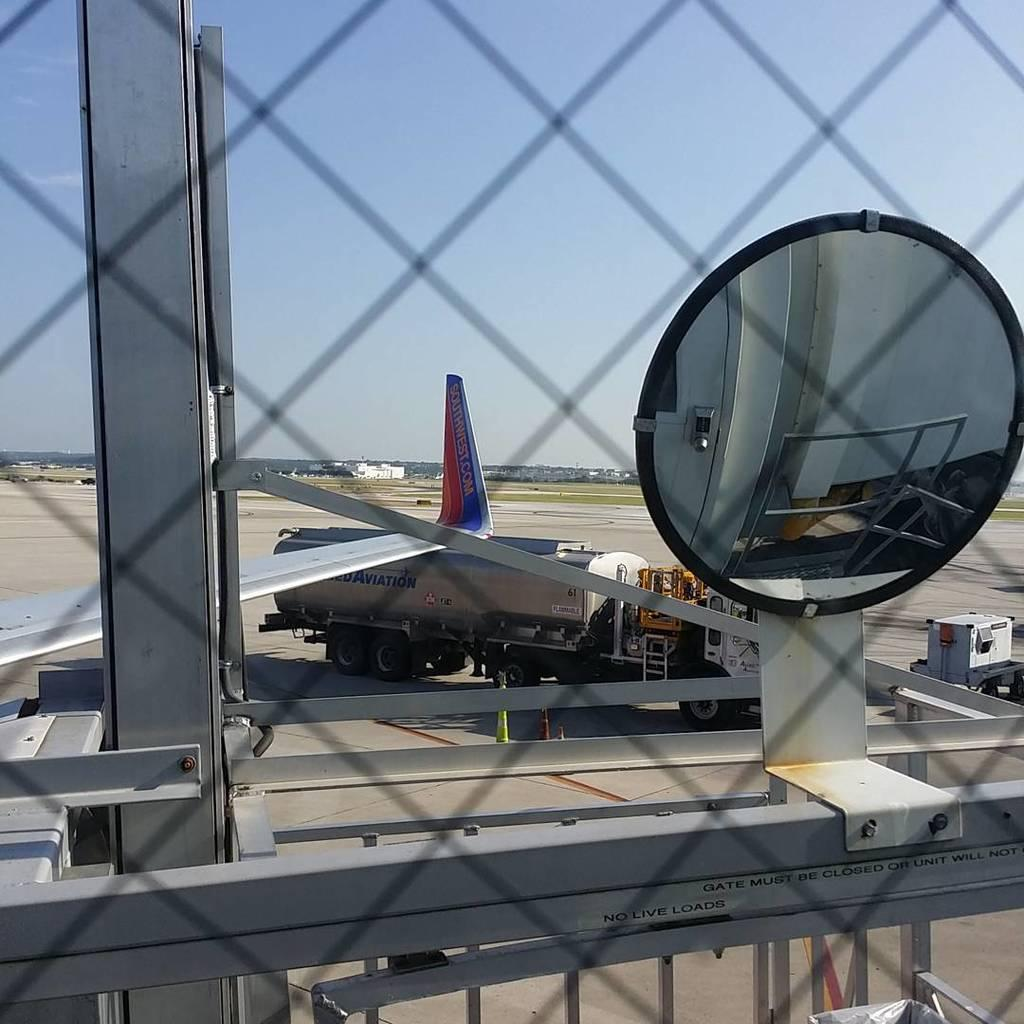<image>
Relay a brief, clear account of the picture shown. Plane parked near a truck with the word AVIATION on it's back. 